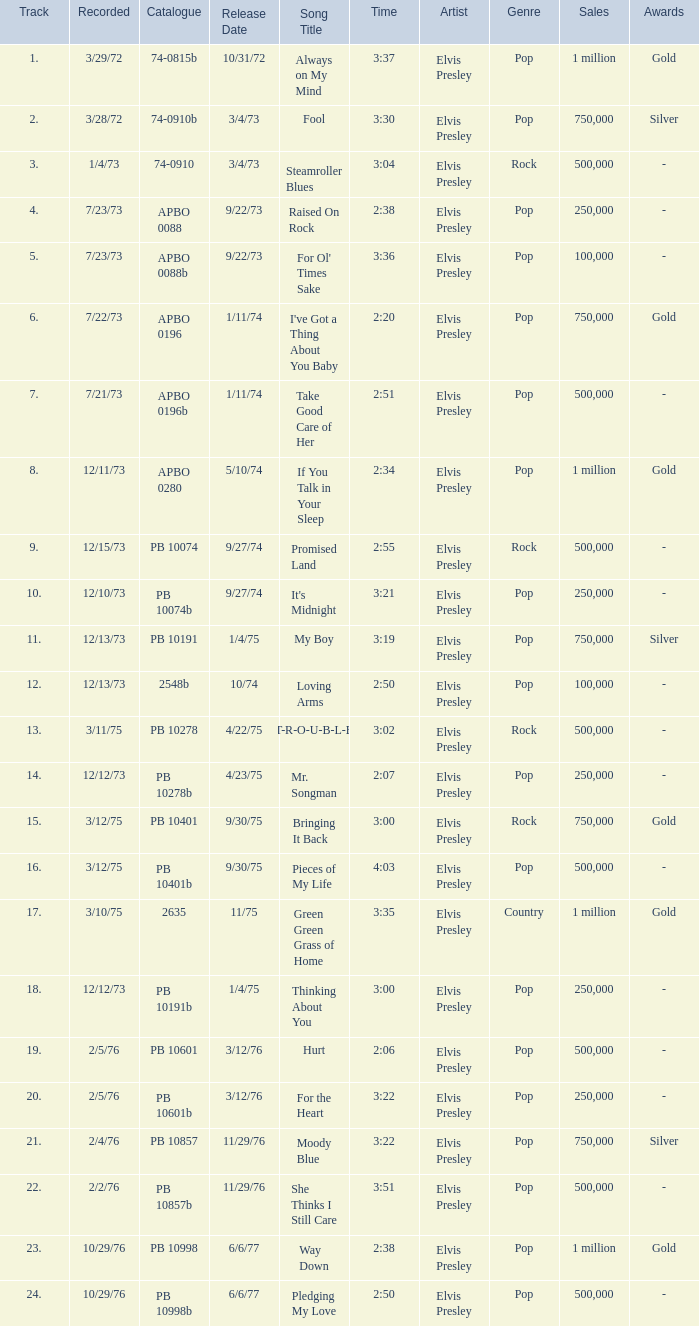Tell me the recorded for time of 2:50 and released date of 6/6/77 with track more than 20 10/29/76. 